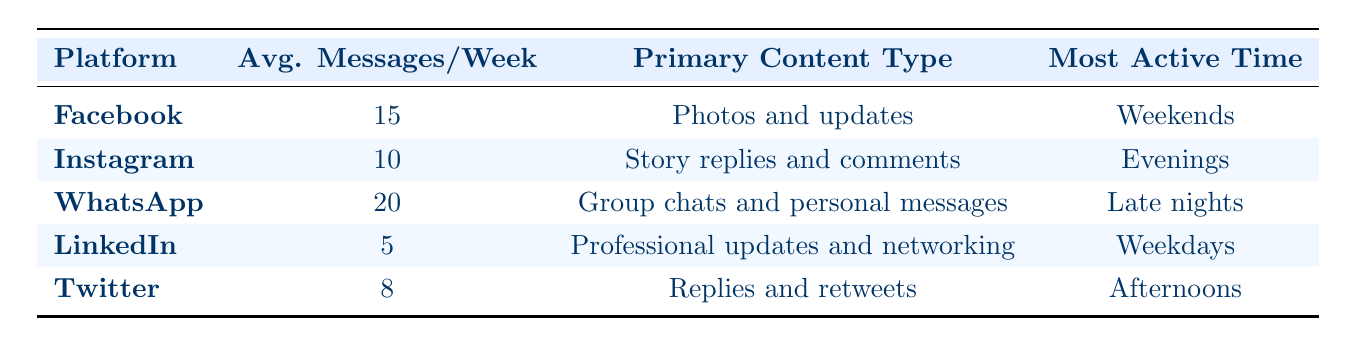What platform has the highest average messages per week? By looking at the "Avg. Messages/Week" column, WhatsApp has the highest average at 20 messages per week compared to the other platforms listed.
Answer: WhatsApp How many average messages per week do all platforms combined generate? To find the total, we add the average messages: 15 (Facebook) + 10 (Instagram) + 20 (WhatsApp) + 5 (LinkedIn) + 8 (Twitter) = 58 messages/week.
Answer: 58 Is the primary content type for LinkedIn focused on personal updates? The primary content type for LinkedIn is "Professional updates and networking," which does not indicate personal updates. Therefore, the statement is false.
Answer: No What is the difference in average messages per week between WhatsApp and LinkedIn? The average messages for WhatsApp is 20 and for LinkedIn is 5. The difference is 20 - 5 = 15 messages per week.
Answer: 15 During which time are Instagram users most active? The table indicates that Instagram users are most active during the "Evenings," which is specified in the "Most Active Time" column for Instagram.
Answer: Evenings Is the number of average messages per week for Twitter greater than that for Instagram? Twitter has 8 average messages per week while Instagram has 10. Since 8 is less than 10, the statement is false.
Answer: No Which platform has the least amount of messaging per week? By examining the "Avg. Messages/Week" column, LinkedIn has the least amount with an average of 5 messages per week.
Answer: LinkedIn What is the average number of messages per week for the top three platforms? The top three platforms by average messages per week are WhatsApp (20), Facebook (15), and Instagram (10). Total messages = 20 + 15 + 10 = 45, and the average is 45/3 = 15.
Answer: 15 